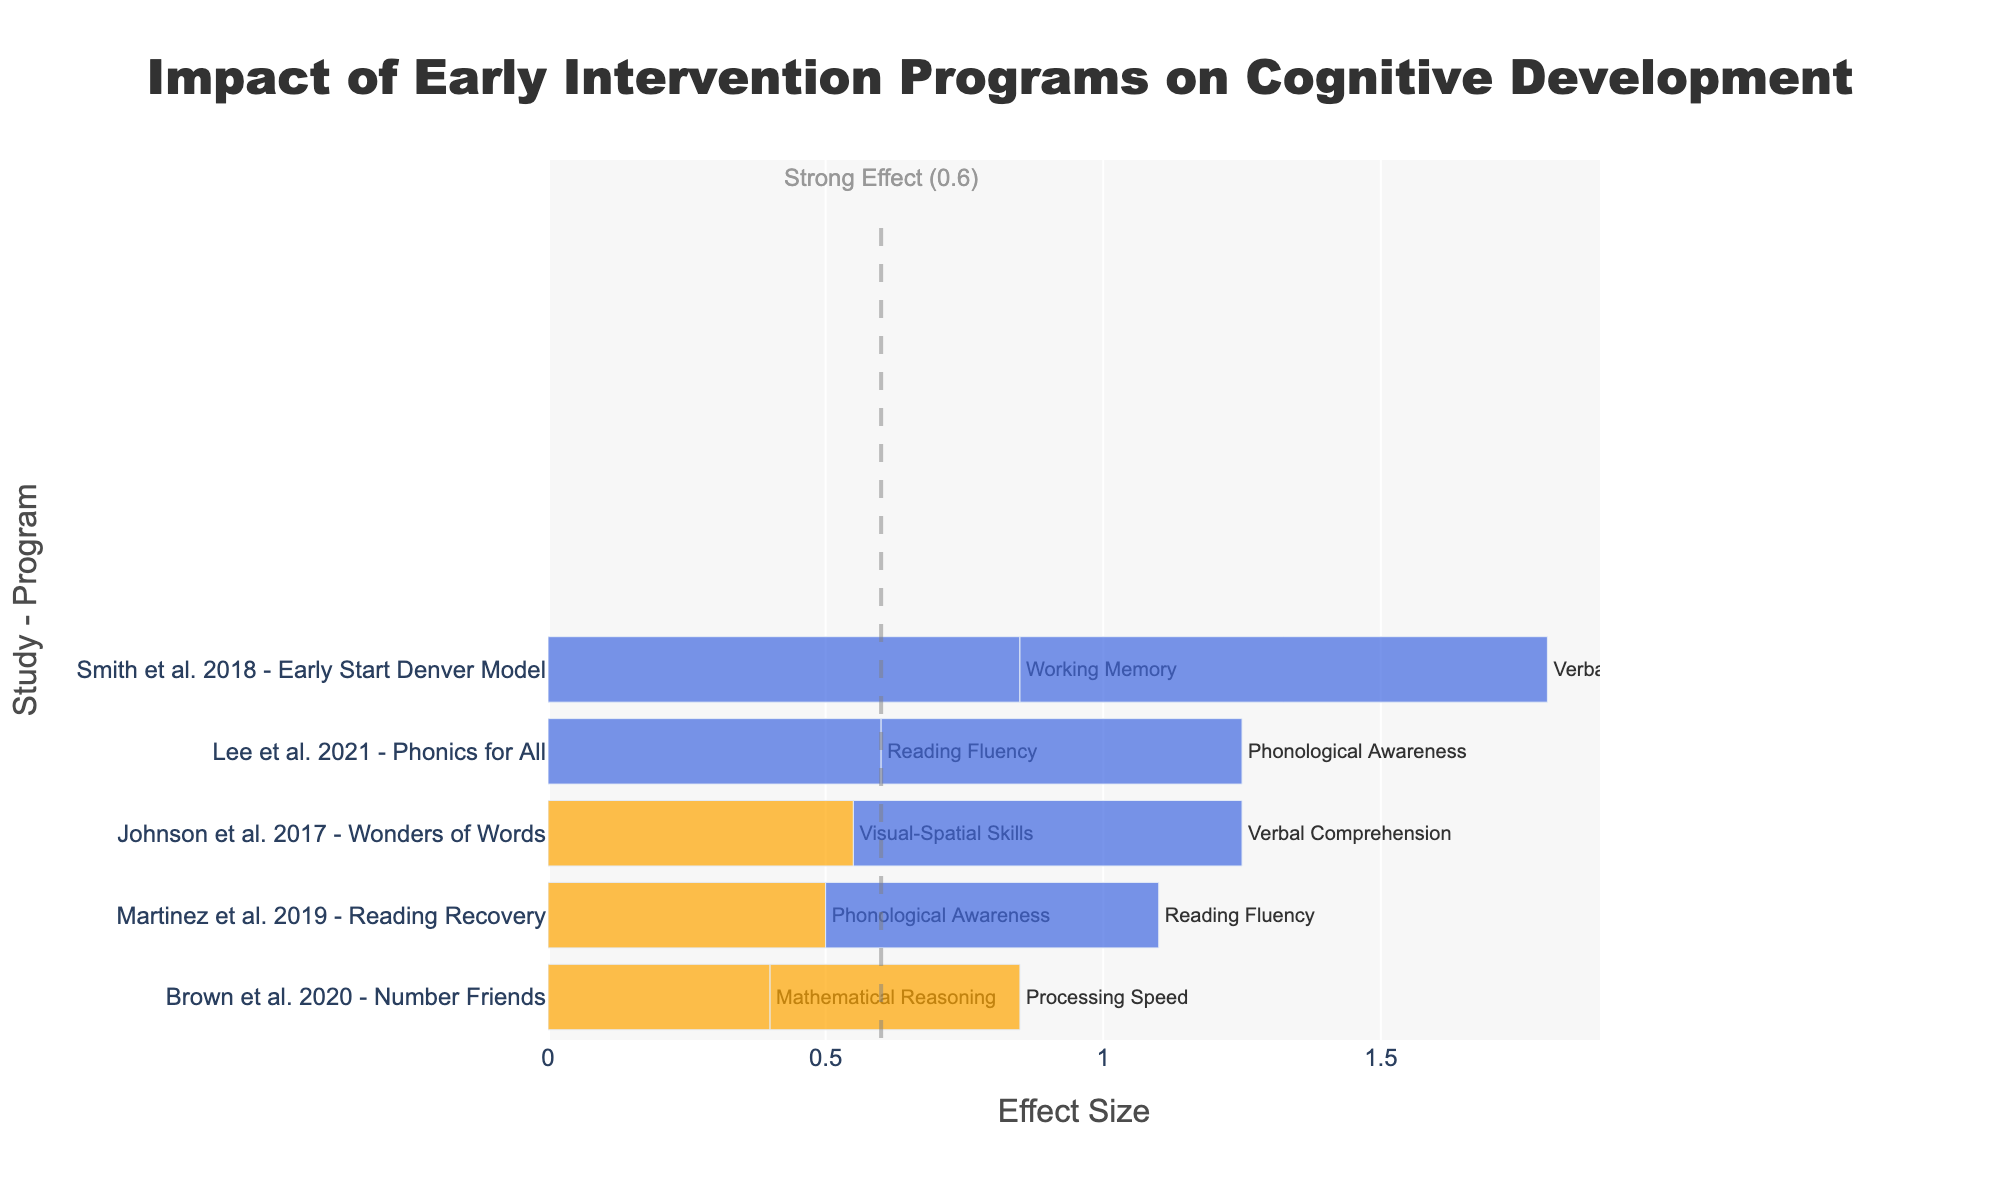Which intervention program showed the highest effect size for verbal comprehension? Locate the bars labeled "Verbal Comprehension" to find the highest effect size. The "Early Start Denver Model" has the highest effect size of 0.95 for verbal comprehension.
Answer: Early Start Denver Model How many intervention programs have an effect size greater than 0.6? Identify the bars where the effect size is greater than the threshold of 0.6. There are four such bars corresponding to "Early Start Denver Model" (2 times), "Wonders of Words", and "Phonics for All" (2 times).
Answer: 5 Which cognitive skill has the highest average effect size across all intervention programs? Calculate the average effect size for each cognitive skill: Verbal Comprehension: (0.95 + 0.70) / 2 = 0.825, Working Memory: 0.85, Visual-Spatial Skills: 0.55, Reading Fluency: (0.60 + 0.60) / 2 = 0.60, Phonological Awareness: (0.50 + 0.65) / 2 = 0.575, Mathematical Reasoning: 0.40, Processing Speed: 0.45. Verbal Comprehension has the highest average effect size.
Answer: Verbal Comprehension Which program has the smallest effect size, and what cognitive skill does it target? Locate the smallest bar in the chart for the lowest effect size, which corresponds to "Number Friends" with an effect size of 0.40. This targets Mathematical Reasoning.
Answer: Number Friends, Mathematical Reasoning Compare the effect sizes of Phonological Awareness for "Reading Recovery" and "Phonics for All". Which one is higher, and by how much? Identify the bars for Phonological Awareness under "Reading Recovery" (0.50) and "Phonics for All" (0.65). Subtract the effect size of "Reading Recovery" from "Phonics for All": 0.65 - 0.50 = 0.15. "Phonics for All" is higher by 0.15.
Answer: Phonics for All, 0.15 Identify the studies where the effect size for cognitive skills is marked in blue. Visualize the bars colored blue (effect size >= 0.6). The corresponding studies are "Smith et al. 2018" (for Verbal Comprehension and Working Memory), "Johnson et al. 2017" (for Verbal Comprehension), and "Lee et al. 2021" (for Phonological Awareness and Reading Fluency).
Answer: Smith et al. 2018, Johnson et al. 2017, Lee et al. 2021 What is the total effect size for "Reading Recovery" across all cognitive skills it targets? Sum the effect sizes for "Reading Recovery": 0.60 (Reading Fluency) + 0.50 (Phonological Awareness) = 1.10.
Answer: 1.10 